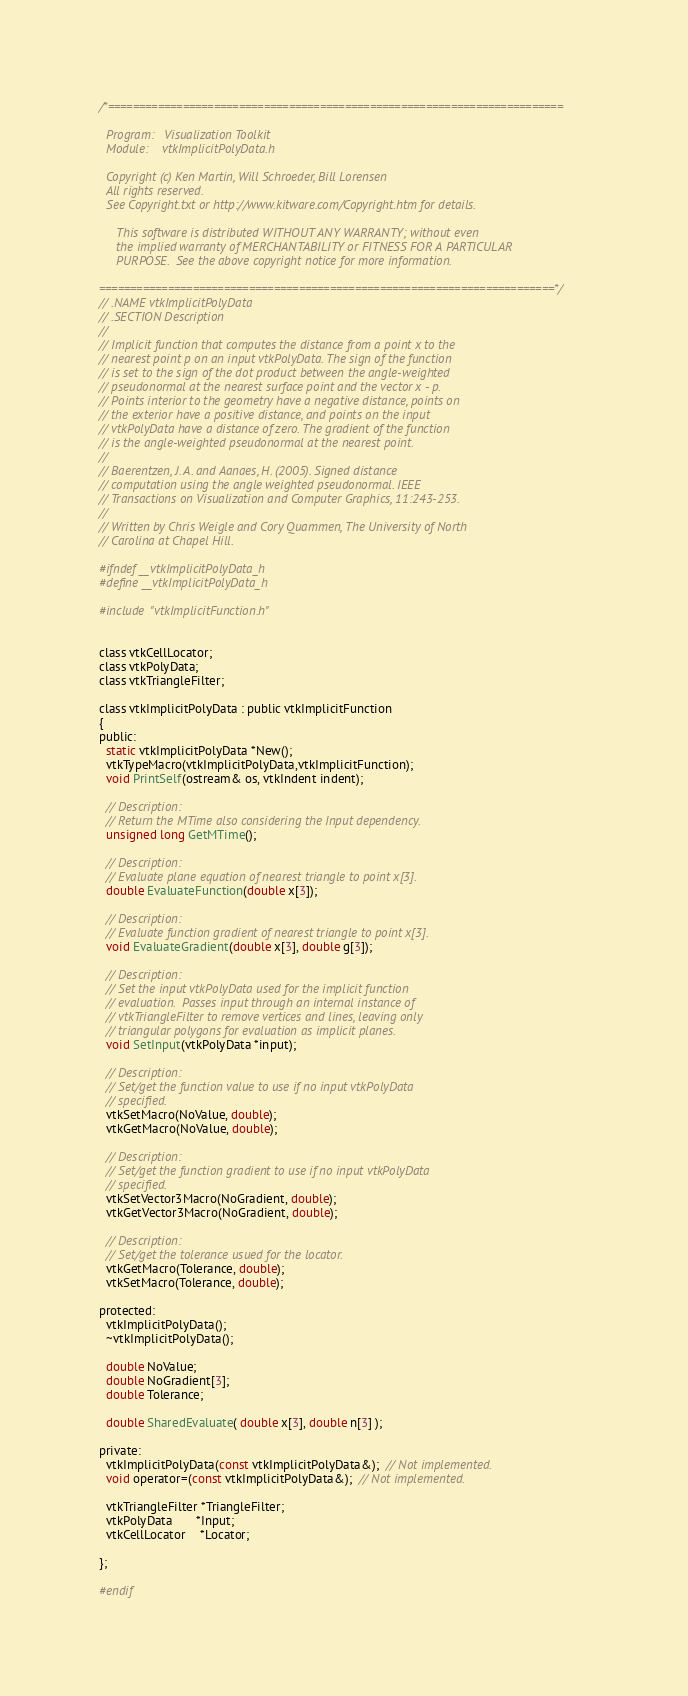Convert code to text. <code><loc_0><loc_0><loc_500><loc_500><_C_>/*=========================================================================

  Program:   Visualization Toolkit
  Module:    vtkImplicitPolyData.h

  Copyright (c) Ken Martin, Will Schroeder, Bill Lorensen
  All rights reserved.
  See Copyright.txt or http://www.kitware.com/Copyright.htm for details.

     This software is distributed WITHOUT ANY WARRANTY; without even
     the implied warranty of MERCHANTABILITY or FITNESS FOR A PARTICULAR
     PURPOSE.  See the above copyright notice for more information.

=========================================================================*/
// .NAME vtkImplicitPolyData
// .SECTION Description
//
// Implicit function that computes the distance from a point x to the
// nearest point p on an input vtkPolyData. The sign of the function
// is set to the sign of the dot product between the angle-weighted
// pseudonormal at the nearest surface point and the vector x - p.
// Points interior to the geometry have a negative distance, points on
// the exterior have a positive distance, and points on the input
// vtkPolyData have a distance of zero. The gradient of the function
// is the angle-weighted pseudonormal at the nearest point.
//
// Baerentzen, J. A. and Aanaes, H. (2005). Signed distance
// computation using the angle weighted pseudonormal. IEEE
// Transactions on Visualization and Computer Graphics, 11:243-253.
//
// Written by Chris Weigle and Cory Quammen, The University of North
// Carolina at Chapel Hill.

#ifndef __vtkImplicitPolyData_h
#define __vtkImplicitPolyData_h

#include "vtkImplicitFunction.h"


class vtkCellLocator;
class vtkPolyData;
class vtkTriangleFilter;

class vtkImplicitPolyData : public vtkImplicitFunction
{
public:
  static vtkImplicitPolyData *New();
  vtkTypeMacro(vtkImplicitPolyData,vtkImplicitFunction);
  void PrintSelf(ostream& os, vtkIndent indent);

  // Description:
  // Return the MTime also considering the Input dependency.
  unsigned long GetMTime();

  // Description:
  // Evaluate plane equation of nearest triangle to point x[3].
  double EvaluateFunction(double x[3]);

  // Description:
  // Evaluate function gradient of nearest triangle to point x[3].
  void EvaluateGradient(double x[3], double g[3]);

  // Description:
  // Set the input vtkPolyData used for the implicit function
  // evaluation.  Passes input through an internal instance of
  // vtkTriangleFilter to remove vertices and lines, leaving only
  // triangular polygons for evaluation as implicit planes.
  void SetInput(vtkPolyData *input);

  // Description:
  // Set/get the function value to use if no input vtkPolyData
  // specified.
  vtkSetMacro(NoValue, double);
  vtkGetMacro(NoValue, double);

  // Description:
  // Set/get the function gradient to use if no input vtkPolyData
  // specified.
  vtkSetVector3Macro(NoGradient, double);
  vtkGetVector3Macro(NoGradient, double);

  // Description:
  // Set/get the tolerance usued for the locator.
  vtkGetMacro(Tolerance, double);
  vtkSetMacro(Tolerance, double);

protected:
  vtkImplicitPolyData();
  ~vtkImplicitPolyData();

  double NoValue;
  double NoGradient[3];
  double Tolerance;

  double SharedEvaluate( double x[3], double n[3] );

private:
  vtkImplicitPolyData(const vtkImplicitPolyData&);  // Not implemented.
  void operator=(const vtkImplicitPolyData&);  // Not implemented.

  vtkTriangleFilter *TriangleFilter;
  vtkPolyData       *Input;
  vtkCellLocator    *Locator;

};

#endif
</code> 